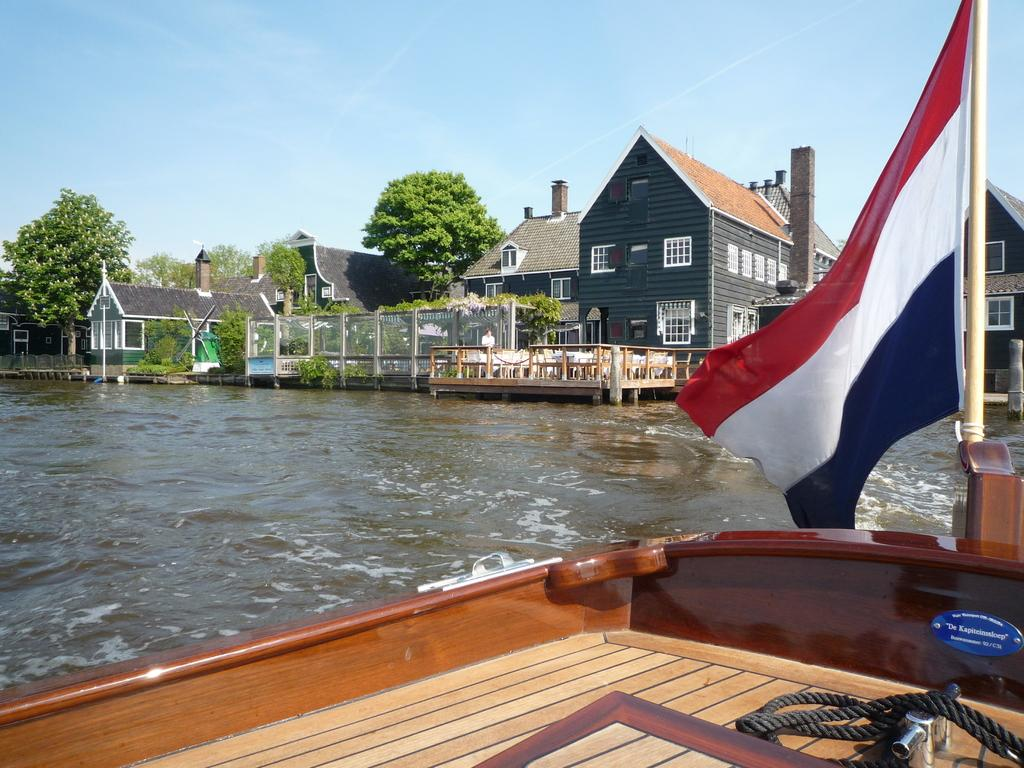What is the main subject of the image? There is a boat on the water in the image. What else can be seen in the background of the image? There are houses and trees visible in the image. What is the person in the image doing? There is a person standing in front of chairs and tables in the image. What type of barrier is present in the image? There is fencing in the image. How many geese are swimming in the stream in the image? There is no stream or geese present in the image. What type of smoke can be seen coming from the boat in the image? There is no smoke coming from the boat in the image. 